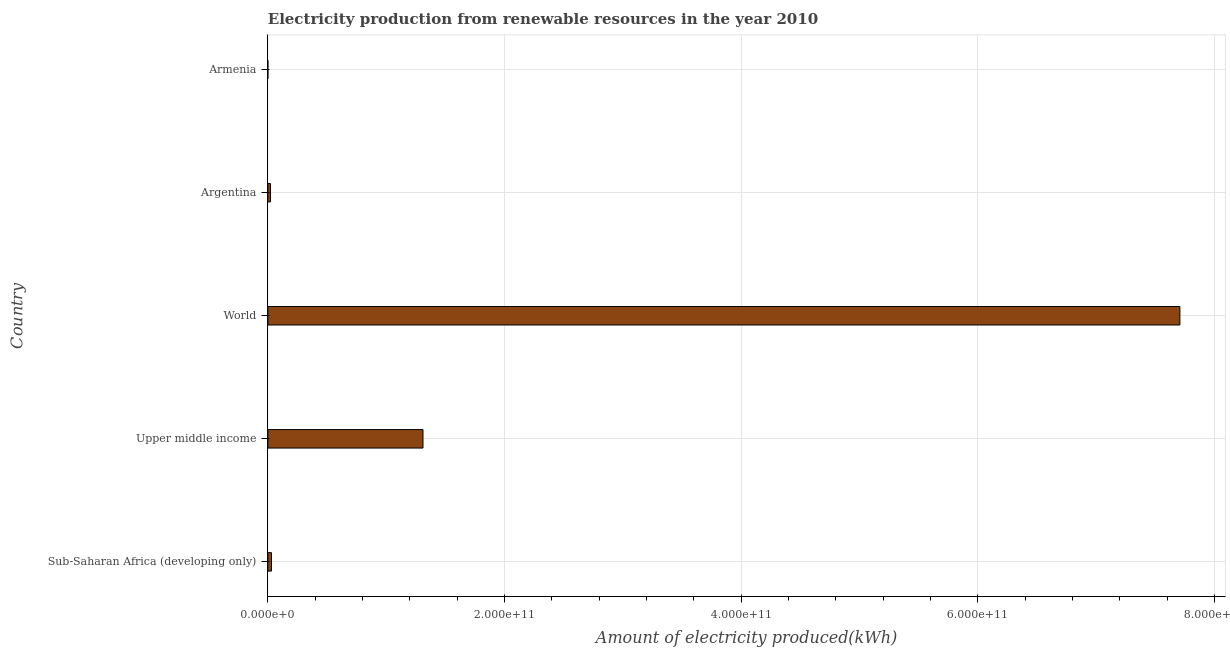What is the title of the graph?
Your answer should be compact. Electricity production from renewable resources in the year 2010. What is the label or title of the X-axis?
Provide a short and direct response. Amount of electricity produced(kWh). What is the label or title of the Y-axis?
Provide a short and direct response. Country. Across all countries, what is the maximum amount of electricity produced?
Make the answer very short. 7.71e+11. In which country was the amount of electricity produced maximum?
Offer a terse response. World. In which country was the amount of electricity produced minimum?
Your answer should be very brief. Armenia. What is the sum of the amount of electricity produced?
Provide a short and direct response. 9.07e+11. What is the difference between the amount of electricity produced in Armenia and Upper middle income?
Your answer should be very brief. -1.31e+11. What is the average amount of electricity produced per country?
Keep it short and to the point. 1.81e+11. What is the median amount of electricity produced?
Offer a very short reply. 3.06e+09. In how many countries, is the amount of electricity produced greater than 40000000000 kWh?
Your response must be concise. 2. What is the ratio of the amount of electricity produced in Argentina to that in Upper middle income?
Offer a terse response. 0.02. Is the amount of electricity produced in Sub-Saharan Africa (developing only) less than that in World?
Keep it short and to the point. Yes. Is the difference between the amount of electricity produced in Argentina and Upper middle income greater than the difference between any two countries?
Provide a succinct answer. No. What is the difference between the highest and the second highest amount of electricity produced?
Give a very brief answer. 6.40e+11. Is the sum of the amount of electricity produced in Sub-Saharan Africa (developing only) and Upper middle income greater than the maximum amount of electricity produced across all countries?
Ensure brevity in your answer.  No. What is the difference between the highest and the lowest amount of electricity produced?
Offer a very short reply. 7.71e+11. What is the difference between two consecutive major ticks on the X-axis?
Your response must be concise. 2.00e+11. What is the Amount of electricity produced(kWh) of Sub-Saharan Africa (developing only)?
Offer a very short reply. 3.06e+09. What is the Amount of electricity produced(kWh) in Upper middle income?
Your answer should be very brief. 1.31e+11. What is the Amount of electricity produced(kWh) in World?
Make the answer very short. 7.71e+11. What is the Amount of electricity produced(kWh) of Argentina?
Your response must be concise. 2.22e+09. What is the difference between the Amount of electricity produced(kWh) in Sub-Saharan Africa (developing only) and Upper middle income?
Offer a terse response. -1.28e+11. What is the difference between the Amount of electricity produced(kWh) in Sub-Saharan Africa (developing only) and World?
Provide a short and direct response. -7.68e+11. What is the difference between the Amount of electricity produced(kWh) in Sub-Saharan Africa (developing only) and Argentina?
Your response must be concise. 8.44e+08. What is the difference between the Amount of electricity produced(kWh) in Sub-Saharan Africa (developing only) and Armenia?
Your answer should be very brief. 3.06e+09. What is the difference between the Amount of electricity produced(kWh) in Upper middle income and World?
Ensure brevity in your answer.  -6.40e+11. What is the difference between the Amount of electricity produced(kWh) in Upper middle income and Argentina?
Keep it short and to the point. 1.29e+11. What is the difference between the Amount of electricity produced(kWh) in Upper middle income and Armenia?
Offer a very short reply. 1.31e+11. What is the difference between the Amount of electricity produced(kWh) in World and Argentina?
Your answer should be very brief. 7.69e+11. What is the difference between the Amount of electricity produced(kWh) in World and Armenia?
Ensure brevity in your answer.  7.71e+11. What is the difference between the Amount of electricity produced(kWh) in Argentina and Armenia?
Your answer should be very brief. 2.21e+09. What is the ratio of the Amount of electricity produced(kWh) in Sub-Saharan Africa (developing only) to that in Upper middle income?
Your answer should be very brief. 0.02. What is the ratio of the Amount of electricity produced(kWh) in Sub-Saharan Africa (developing only) to that in World?
Make the answer very short. 0. What is the ratio of the Amount of electricity produced(kWh) in Sub-Saharan Africa (developing only) to that in Argentina?
Make the answer very short. 1.38. What is the ratio of the Amount of electricity produced(kWh) in Sub-Saharan Africa (developing only) to that in Armenia?
Offer a very short reply. 437.43. What is the ratio of the Amount of electricity produced(kWh) in Upper middle income to that in World?
Your response must be concise. 0.17. What is the ratio of the Amount of electricity produced(kWh) in Upper middle income to that in Argentina?
Provide a short and direct response. 59.12. What is the ratio of the Amount of electricity produced(kWh) in Upper middle income to that in Armenia?
Make the answer very short. 1.87e+04. What is the ratio of the Amount of electricity produced(kWh) in World to that in Argentina?
Your answer should be compact. 347.53. What is the ratio of the Amount of electricity produced(kWh) in World to that in Armenia?
Ensure brevity in your answer.  1.10e+05. What is the ratio of the Amount of electricity produced(kWh) in Argentina to that in Armenia?
Your response must be concise. 316.86. 